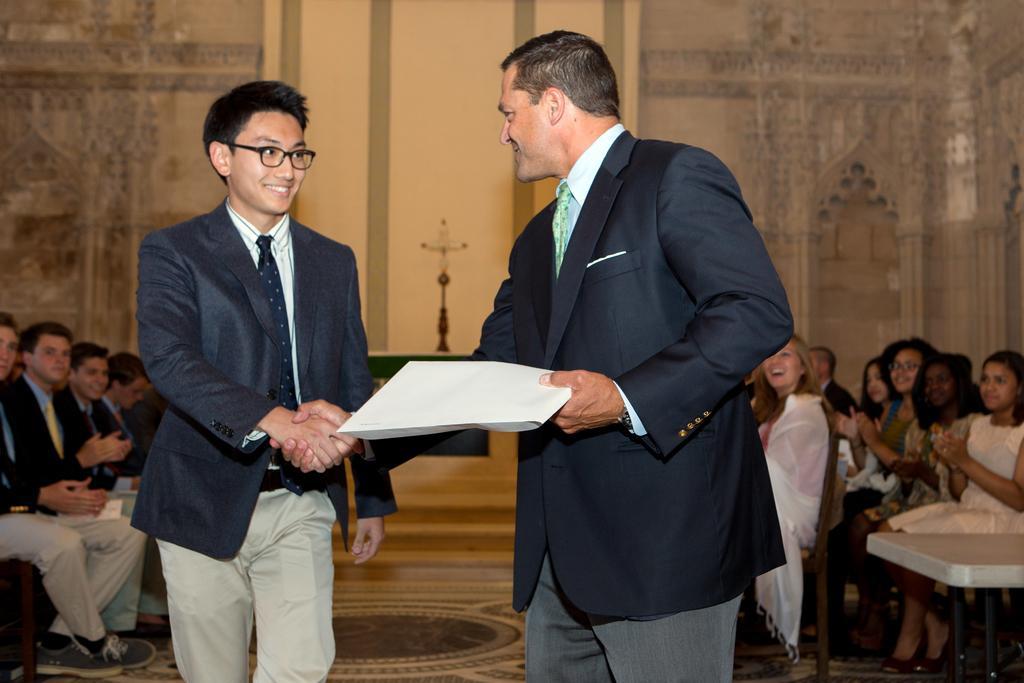Can you describe this image briefly? Two guys are hand shaking each other. There are many people around them. There is a plus sign in the background. One man is catching a book. There is also a table located at the right side of the image. People around them are clapping hands. There is a good carpet on the floor. 